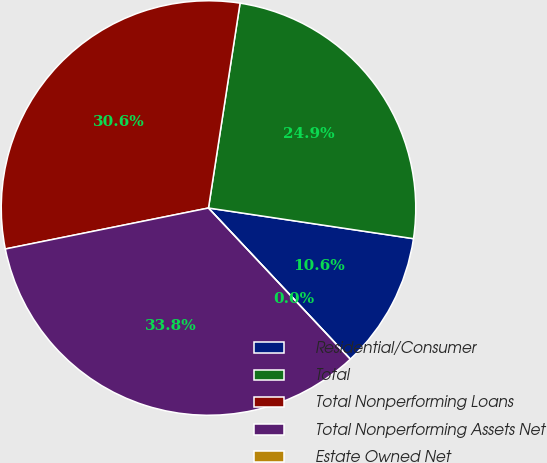Convert chart to OTSL. <chart><loc_0><loc_0><loc_500><loc_500><pie_chart><fcel>Residential/Consumer<fcel>Total<fcel>Total Nonperforming Loans<fcel>Total Nonperforming Assets Net<fcel>Estate Owned Net<nl><fcel>10.64%<fcel>24.93%<fcel>30.6%<fcel>33.83%<fcel>0.0%<nl></chart> 